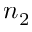<formula> <loc_0><loc_0><loc_500><loc_500>n _ { 2 }</formula> 